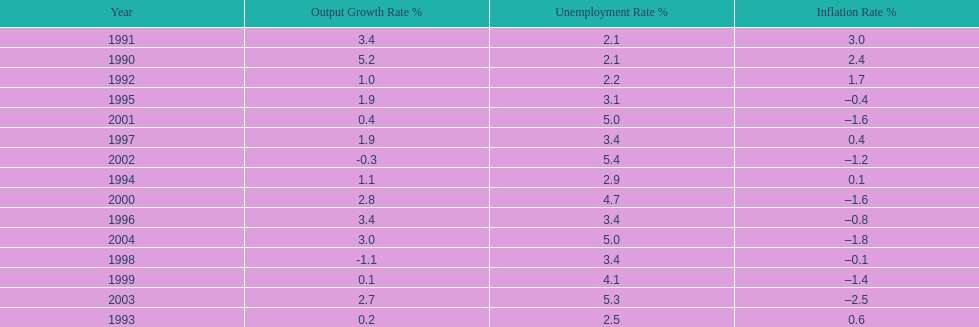What year saw the highest output growth rate in japan between the years 1990 and 2004? 1990. 